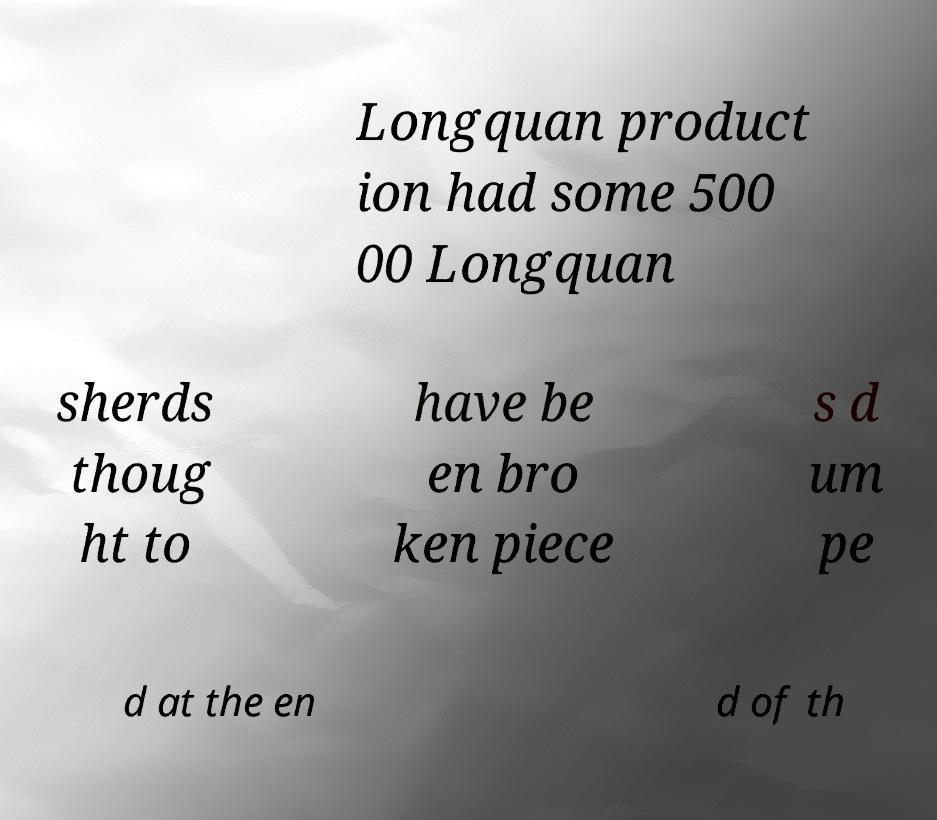There's text embedded in this image that I need extracted. Can you transcribe it verbatim? Longquan product ion had some 500 00 Longquan sherds thoug ht to have be en bro ken piece s d um pe d at the en d of th 